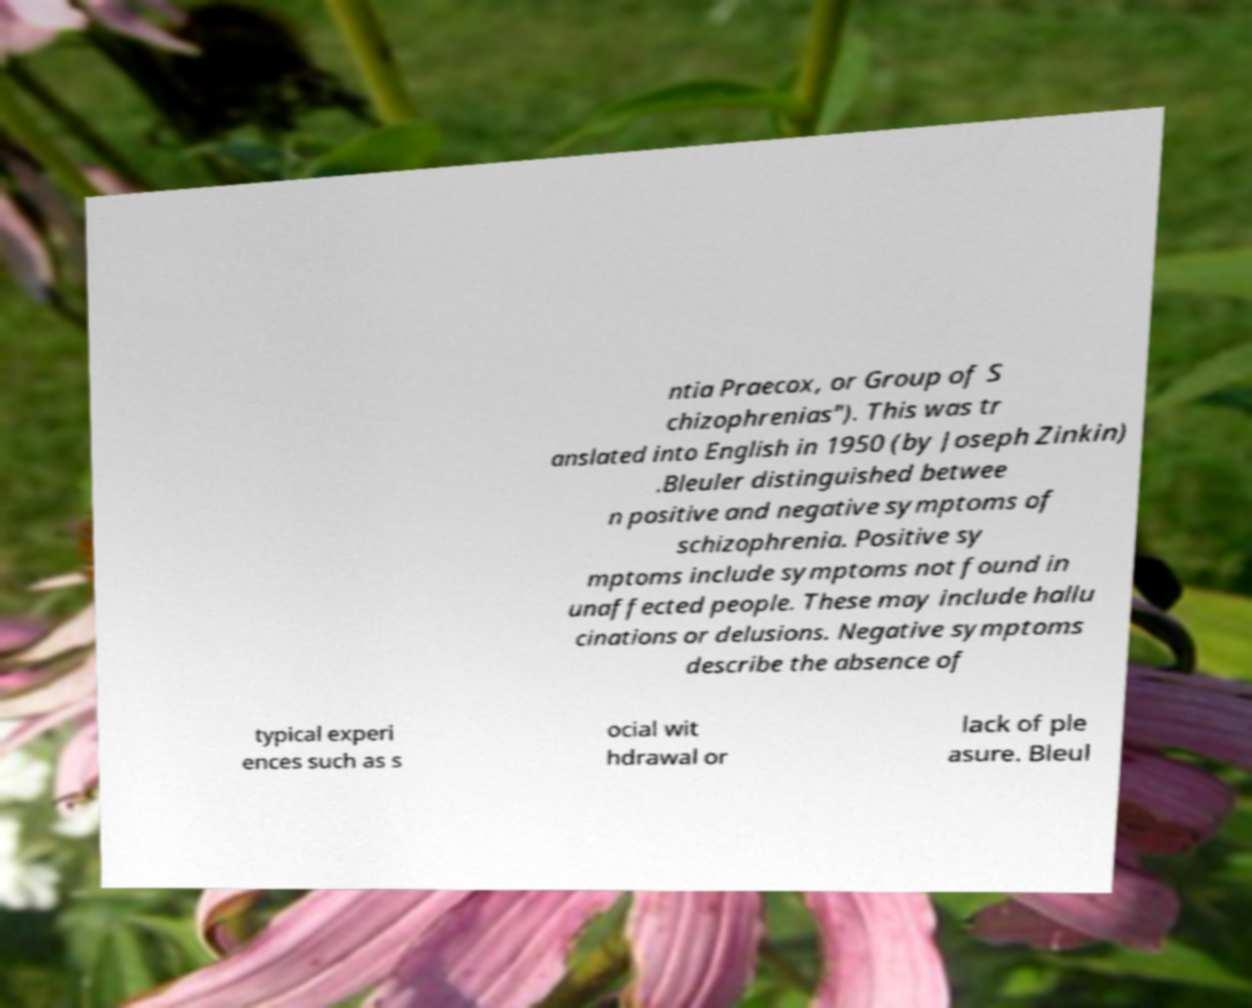I need the written content from this picture converted into text. Can you do that? ntia Praecox, or Group of S chizophrenias"). This was tr anslated into English in 1950 (by Joseph Zinkin) .Bleuler distinguished betwee n positive and negative symptoms of schizophrenia. Positive sy mptoms include symptoms not found in unaffected people. These may include hallu cinations or delusions. Negative symptoms describe the absence of typical experi ences such as s ocial wit hdrawal or lack of ple asure. Bleul 